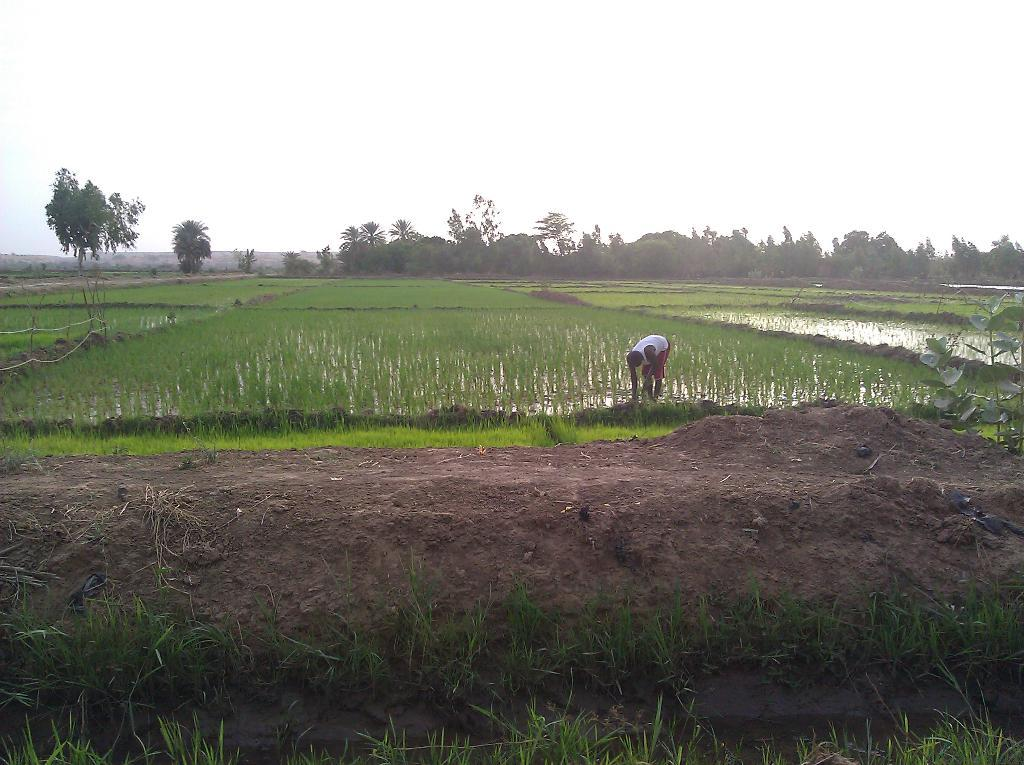What type of terrain is visible in the image? There is mud and grass in the image. Can you describe the person in the fields? There is a person in the fields. What can be seen in the background of the image? There are trees and the sky visible in the background of the image. Reasoning: Let' Let's think step by step in order to produce the conversation. We start by identifying the main elements of the image, which are the mud and grass. Then, we mention the presence of a person in the fields. Finally, we describe the background, which includes trees and the sky. We avoid asking questions that cannot be answered definitively and ensure that the language is simple and clear. Absurd Question/Answer: How many zebras are grazing in the grass in the image? There are no zebras present in the image; it features mud, grass, and a person in the fields. What achievement has the person in the fields accomplished, as depicted in the image? The image does not show any specific achievements or accomplishments of the person in the fields. 